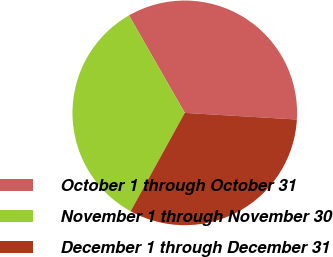Convert chart to OTSL. <chart><loc_0><loc_0><loc_500><loc_500><pie_chart><fcel>October 1 through October 31<fcel>November 1 through November 30<fcel>December 1 through December 31<nl><fcel>34.22%<fcel>33.71%<fcel>32.06%<nl></chart> 